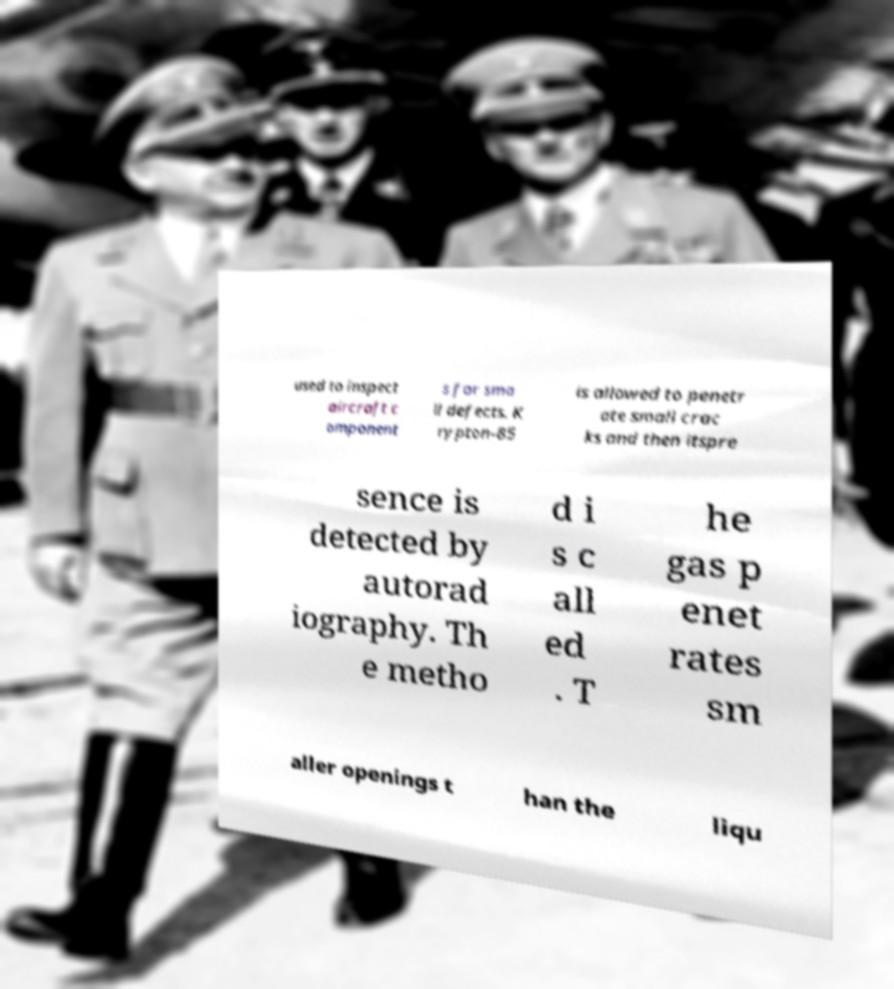Could you assist in decoding the text presented in this image and type it out clearly? used to inspect aircraft c omponent s for sma ll defects. K rypton-85 is allowed to penetr ate small crac ks and then itspre sence is detected by autorad iography. Th e metho d i s c all ed . T he gas p enet rates sm aller openings t han the liqu 